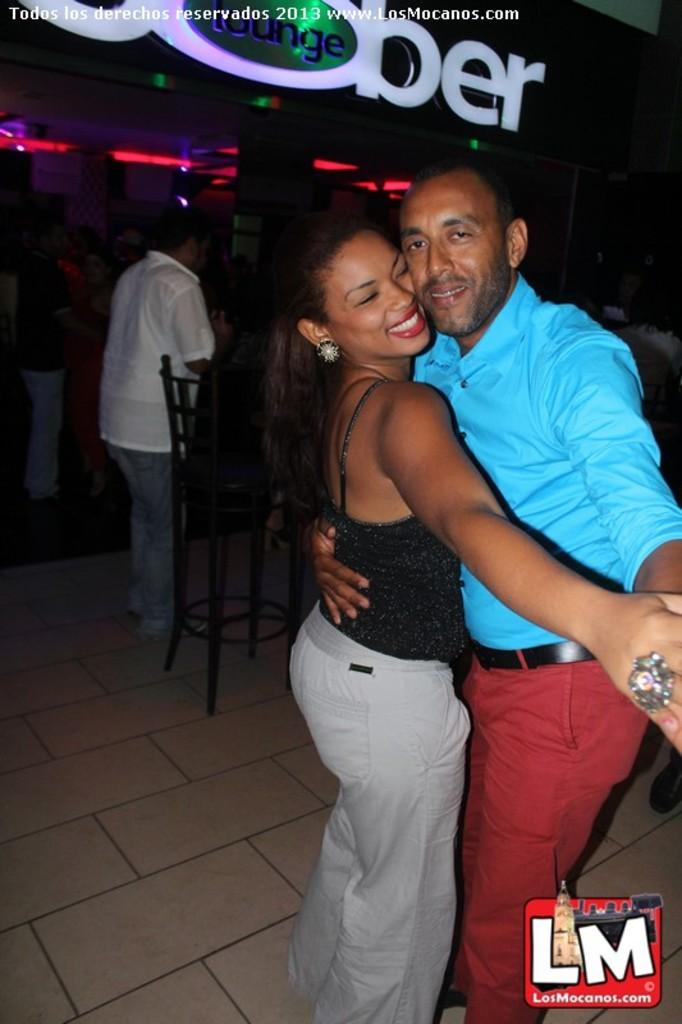What are the main subjects in the foreground of the image? There is a couple dancing in the foreground of the picture. What can be seen at the bottom of the image? There is a logo at the bottom of the image. What is visible in the background of the image? There are chairs, people, text, and lights in the background of the image. Can you describe the text visible in the image? There is text visible at the top and in the background of the image. How many muscles does the man in the image have? The number of muscles a person has cannot be determined from the image. What type of addition is being performed by the people in the background? There is no indication of any mathematical addition being performed by the people in the image. 